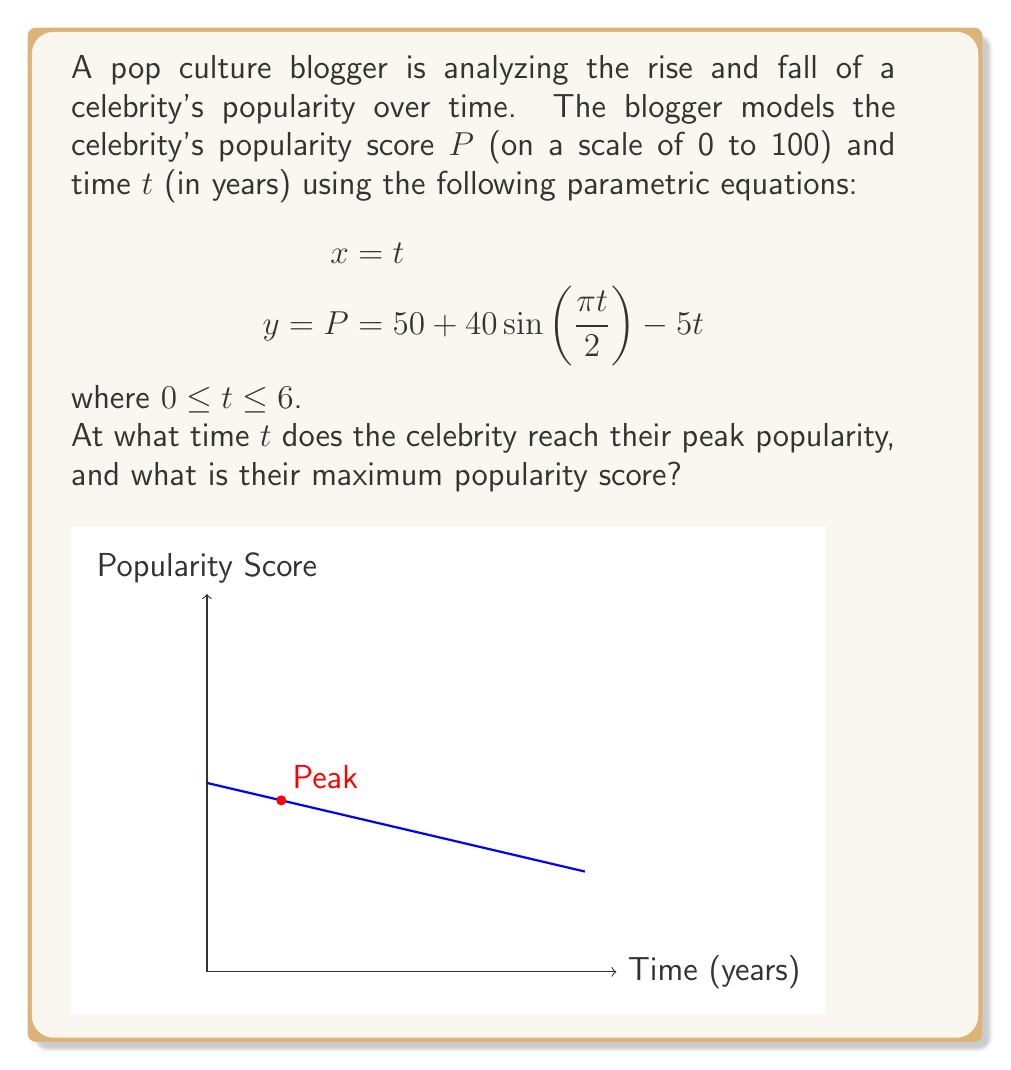Provide a solution to this math problem. To find the celebrity's peak popularity, we need to determine the maximum value of $P$ within the given time interval. Let's approach this step-by-step:

1) First, we need to find the derivative of $P$ with respect to $t$:

   $$\frac{dP}{dt} = 40 \cdot \frac{\pi}{2} \cos(\frac{\pi t}{2}) - 5$$

2) To find the maximum, we set this derivative equal to zero and solve for $t$:

   $$40 \cdot \frac{\pi}{2} \cos(\frac{\pi t}{2}) - 5 = 0$$
   $$20\pi \cos(\frac{\pi t}{2}) = 5$$
   $$\cos(\frac{\pi t}{2}) = \frac{1}{4\pi}$$

3) Taking the inverse cosine of both sides:

   $$\frac{\pi t}{2} = \arccos(\frac{1}{4\pi})$$
   $$t = \frac{2}{\pi} \arccos(\frac{1}{4\pi}) \approx 1.18 \text{ years}$$

4) To verify this is a maximum (not a minimum), we can check that the second derivative is negative at this point (omitted for brevity).

5) Now, we can calculate the maximum popularity by plugging this $t$ value into our original equation for $P$:

   $$P_{max} = 50 + 40\sin(\frac{\pi \cdot 1.18}{2}) - 5 \cdot 1.18 \approx 88.97$$

Therefore, the celebrity reaches peak popularity after approximately 1.18 years, with a popularity score of about 88.97.
Answer: $t \approx 1.18$ years, $P_{max} \approx 88.97$ 